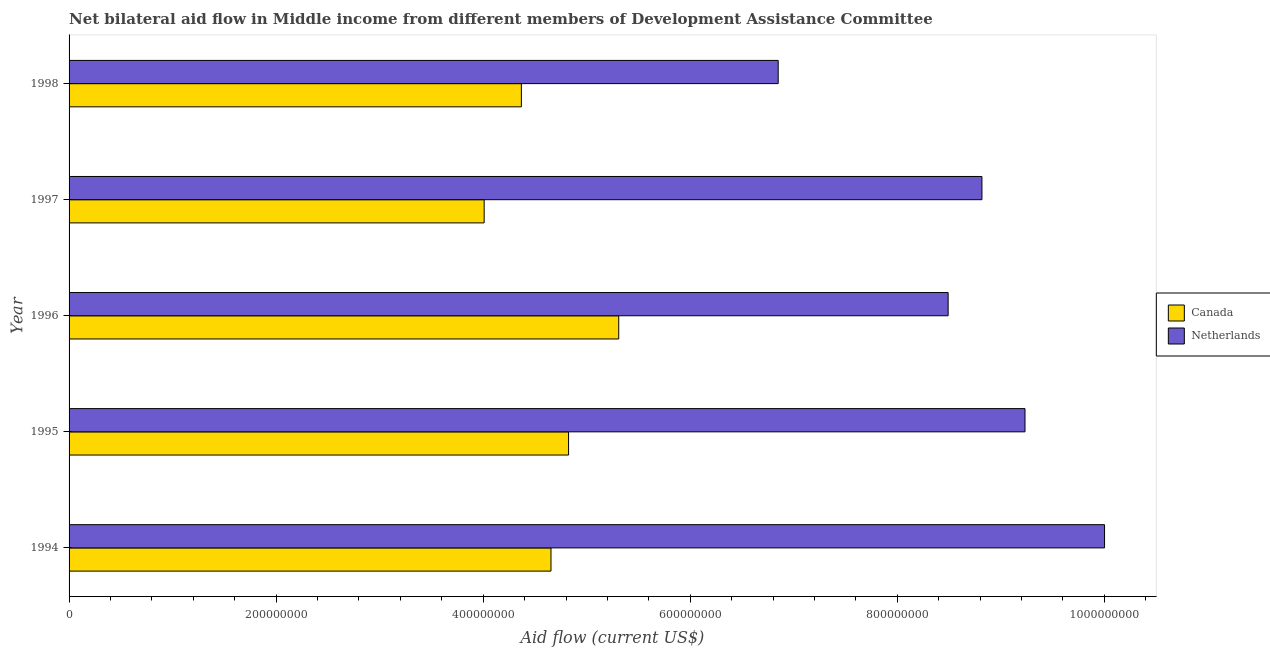How many bars are there on the 3rd tick from the bottom?
Ensure brevity in your answer.  2. What is the label of the 1st group of bars from the top?
Provide a succinct answer. 1998. What is the amount of aid given by netherlands in 1997?
Offer a terse response. 8.82e+08. Across all years, what is the maximum amount of aid given by canada?
Your answer should be compact. 5.31e+08. Across all years, what is the minimum amount of aid given by netherlands?
Ensure brevity in your answer.  6.85e+08. In which year was the amount of aid given by canada minimum?
Your answer should be compact. 1997. What is the total amount of aid given by canada in the graph?
Give a very brief answer. 2.32e+09. What is the difference between the amount of aid given by canada in 1995 and that in 1997?
Offer a terse response. 8.15e+07. What is the difference between the amount of aid given by canada in 1995 and the amount of aid given by netherlands in 1996?
Your response must be concise. -3.67e+08. What is the average amount of aid given by netherlands per year?
Give a very brief answer. 8.68e+08. In the year 1995, what is the difference between the amount of aid given by netherlands and amount of aid given by canada?
Give a very brief answer. 4.41e+08. In how many years, is the amount of aid given by netherlands greater than 880000000 US$?
Give a very brief answer. 3. What is the ratio of the amount of aid given by netherlands in 1994 to that in 1995?
Offer a very short reply. 1.08. What is the difference between the highest and the second highest amount of aid given by netherlands?
Ensure brevity in your answer.  7.68e+07. What is the difference between the highest and the lowest amount of aid given by canada?
Your answer should be very brief. 1.30e+08. In how many years, is the amount of aid given by netherlands greater than the average amount of aid given by netherlands taken over all years?
Provide a short and direct response. 3. What does the 2nd bar from the bottom in 1998 represents?
Give a very brief answer. Netherlands. How many years are there in the graph?
Give a very brief answer. 5. What is the difference between two consecutive major ticks on the X-axis?
Keep it short and to the point. 2.00e+08. Are the values on the major ticks of X-axis written in scientific E-notation?
Keep it short and to the point. No. Does the graph contain grids?
Your answer should be very brief. No. How are the legend labels stacked?
Provide a succinct answer. Vertical. What is the title of the graph?
Provide a succinct answer. Net bilateral aid flow in Middle income from different members of Development Assistance Committee. Does "Rural Population" appear as one of the legend labels in the graph?
Your answer should be very brief. No. What is the label or title of the X-axis?
Give a very brief answer. Aid flow (current US$). What is the Aid flow (current US$) of Canada in 1994?
Offer a terse response. 4.66e+08. What is the Aid flow (current US$) in Netherlands in 1994?
Provide a succinct answer. 1.00e+09. What is the Aid flow (current US$) of Canada in 1995?
Provide a succinct answer. 4.82e+08. What is the Aid flow (current US$) of Netherlands in 1995?
Offer a very short reply. 9.23e+08. What is the Aid flow (current US$) in Canada in 1996?
Your answer should be very brief. 5.31e+08. What is the Aid flow (current US$) in Netherlands in 1996?
Provide a short and direct response. 8.49e+08. What is the Aid flow (current US$) in Canada in 1997?
Offer a very short reply. 4.01e+08. What is the Aid flow (current US$) in Netherlands in 1997?
Offer a very short reply. 8.82e+08. What is the Aid flow (current US$) of Canada in 1998?
Offer a very short reply. 4.37e+08. What is the Aid flow (current US$) in Netherlands in 1998?
Offer a terse response. 6.85e+08. Across all years, what is the maximum Aid flow (current US$) in Canada?
Offer a very short reply. 5.31e+08. Across all years, what is the maximum Aid flow (current US$) of Netherlands?
Offer a terse response. 1.00e+09. Across all years, what is the minimum Aid flow (current US$) of Canada?
Your answer should be very brief. 4.01e+08. Across all years, what is the minimum Aid flow (current US$) in Netherlands?
Give a very brief answer. 6.85e+08. What is the total Aid flow (current US$) in Canada in the graph?
Your answer should be compact. 2.32e+09. What is the total Aid flow (current US$) in Netherlands in the graph?
Your response must be concise. 4.34e+09. What is the difference between the Aid flow (current US$) of Canada in 1994 and that in 1995?
Offer a terse response. -1.70e+07. What is the difference between the Aid flow (current US$) of Netherlands in 1994 and that in 1995?
Keep it short and to the point. 7.68e+07. What is the difference between the Aid flow (current US$) in Canada in 1994 and that in 1996?
Make the answer very short. -6.54e+07. What is the difference between the Aid flow (current US$) in Netherlands in 1994 and that in 1996?
Give a very brief answer. 1.51e+08. What is the difference between the Aid flow (current US$) in Canada in 1994 and that in 1997?
Provide a succinct answer. 6.46e+07. What is the difference between the Aid flow (current US$) of Netherlands in 1994 and that in 1997?
Your answer should be very brief. 1.18e+08. What is the difference between the Aid flow (current US$) of Canada in 1994 and that in 1998?
Offer a terse response. 2.86e+07. What is the difference between the Aid flow (current US$) of Netherlands in 1994 and that in 1998?
Offer a very short reply. 3.15e+08. What is the difference between the Aid flow (current US$) of Canada in 1995 and that in 1996?
Make the answer very short. -4.85e+07. What is the difference between the Aid flow (current US$) in Netherlands in 1995 and that in 1996?
Make the answer very short. 7.42e+07. What is the difference between the Aid flow (current US$) in Canada in 1995 and that in 1997?
Provide a succinct answer. 8.15e+07. What is the difference between the Aid flow (current US$) of Netherlands in 1995 and that in 1997?
Offer a very short reply. 4.16e+07. What is the difference between the Aid flow (current US$) in Canada in 1995 and that in 1998?
Ensure brevity in your answer.  4.56e+07. What is the difference between the Aid flow (current US$) in Netherlands in 1995 and that in 1998?
Make the answer very short. 2.38e+08. What is the difference between the Aid flow (current US$) in Canada in 1996 and that in 1997?
Provide a short and direct response. 1.30e+08. What is the difference between the Aid flow (current US$) in Netherlands in 1996 and that in 1997?
Offer a terse response. -3.26e+07. What is the difference between the Aid flow (current US$) of Canada in 1996 and that in 1998?
Provide a short and direct response. 9.40e+07. What is the difference between the Aid flow (current US$) in Netherlands in 1996 and that in 1998?
Keep it short and to the point. 1.64e+08. What is the difference between the Aid flow (current US$) in Canada in 1997 and that in 1998?
Provide a succinct answer. -3.60e+07. What is the difference between the Aid flow (current US$) in Netherlands in 1997 and that in 1998?
Your answer should be compact. 1.97e+08. What is the difference between the Aid flow (current US$) of Canada in 1994 and the Aid flow (current US$) of Netherlands in 1995?
Your answer should be very brief. -4.58e+08. What is the difference between the Aid flow (current US$) of Canada in 1994 and the Aid flow (current US$) of Netherlands in 1996?
Offer a very short reply. -3.84e+08. What is the difference between the Aid flow (current US$) of Canada in 1994 and the Aid flow (current US$) of Netherlands in 1997?
Ensure brevity in your answer.  -4.16e+08. What is the difference between the Aid flow (current US$) in Canada in 1994 and the Aid flow (current US$) in Netherlands in 1998?
Offer a very short reply. -2.19e+08. What is the difference between the Aid flow (current US$) in Canada in 1995 and the Aid flow (current US$) in Netherlands in 1996?
Offer a terse response. -3.67e+08. What is the difference between the Aid flow (current US$) in Canada in 1995 and the Aid flow (current US$) in Netherlands in 1997?
Give a very brief answer. -3.99e+08. What is the difference between the Aid flow (current US$) in Canada in 1995 and the Aid flow (current US$) in Netherlands in 1998?
Make the answer very short. -2.02e+08. What is the difference between the Aid flow (current US$) in Canada in 1996 and the Aid flow (current US$) in Netherlands in 1997?
Offer a terse response. -3.51e+08. What is the difference between the Aid flow (current US$) of Canada in 1996 and the Aid flow (current US$) of Netherlands in 1998?
Offer a terse response. -1.54e+08. What is the difference between the Aid flow (current US$) of Canada in 1997 and the Aid flow (current US$) of Netherlands in 1998?
Ensure brevity in your answer.  -2.84e+08. What is the average Aid flow (current US$) in Canada per year?
Offer a very short reply. 4.63e+08. What is the average Aid flow (current US$) of Netherlands per year?
Your response must be concise. 8.68e+08. In the year 1994, what is the difference between the Aid flow (current US$) of Canada and Aid flow (current US$) of Netherlands?
Ensure brevity in your answer.  -5.35e+08. In the year 1995, what is the difference between the Aid flow (current US$) of Canada and Aid flow (current US$) of Netherlands?
Ensure brevity in your answer.  -4.41e+08. In the year 1996, what is the difference between the Aid flow (current US$) in Canada and Aid flow (current US$) in Netherlands?
Keep it short and to the point. -3.18e+08. In the year 1997, what is the difference between the Aid flow (current US$) in Canada and Aid flow (current US$) in Netherlands?
Offer a terse response. -4.81e+08. In the year 1998, what is the difference between the Aid flow (current US$) of Canada and Aid flow (current US$) of Netherlands?
Ensure brevity in your answer.  -2.48e+08. What is the ratio of the Aid flow (current US$) in Canada in 1994 to that in 1995?
Your response must be concise. 0.96. What is the ratio of the Aid flow (current US$) in Netherlands in 1994 to that in 1995?
Give a very brief answer. 1.08. What is the ratio of the Aid flow (current US$) of Canada in 1994 to that in 1996?
Your answer should be compact. 0.88. What is the ratio of the Aid flow (current US$) of Netherlands in 1994 to that in 1996?
Make the answer very short. 1.18. What is the ratio of the Aid flow (current US$) of Canada in 1994 to that in 1997?
Give a very brief answer. 1.16. What is the ratio of the Aid flow (current US$) in Netherlands in 1994 to that in 1997?
Offer a terse response. 1.13. What is the ratio of the Aid flow (current US$) of Canada in 1994 to that in 1998?
Offer a very short reply. 1.07. What is the ratio of the Aid flow (current US$) in Netherlands in 1994 to that in 1998?
Your response must be concise. 1.46. What is the ratio of the Aid flow (current US$) of Canada in 1995 to that in 1996?
Keep it short and to the point. 0.91. What is the ratio of the Aid flow (current US$) in Netherlands in 1995 to that in 1996?
Ensure brevity in your answer.  1.09. What is the ratio of the Aid flow (current US$) of Canada in 1995 to that in 1997?
Make the answer very short. 1.2. What is the ratio of the Aid flow (current US$) of Netherlands in 1995 to that in 1997?
Offer a terse response. 1.05. What is the ratio of the Aid flow (current US$) in Canada in 1995 to that in 1998?
Keep it short and to the point. 1.1. What is the ratio of the Aid flow (current US$) of Netherlands in 1995 to that in 1998?
Give a very brief answer. 1.35. What is the ratio of the Aid flow (current US$) of Canada in 1996 to that in 1997?
Make the answer very short. 1.32. What is the ratio of the Aid flow (current US$) of Canada in 1996 to that in 1998?
Your response must be concise. 1.22. What is the ratio of the Aid flow (current US$) in Netherlands in 1996 to that in 1998?
Provide a short and direct response. 1.24. What is the ratio of the Aid flow (current US$) in Canada in 1997 to that in 1998?
Ensure brevity in your answer.  0.92. What is the ratio of the Aid flow (current US$) in Netherlands in 1997 to that in 1998?
Your response must be concise. 1.29. What is the difference between the highest and the second highest Aid flow (current US$) of Canada?
Provide a short and direct response. 4.85e+07. What is the difference between the highest and the second highest Aid flow (current US$) of Netherlands?
Your response must be concise. 7.68e+07. What is the difference between the highest and the lowest Aid flow (current US$) of Canada?
Keep it short and to the point. 1.30e+08. What is the difference between the highest and the lowest Aid flow (current US$) of Netherlands?
Offer a terse response. 3.15e+08. 